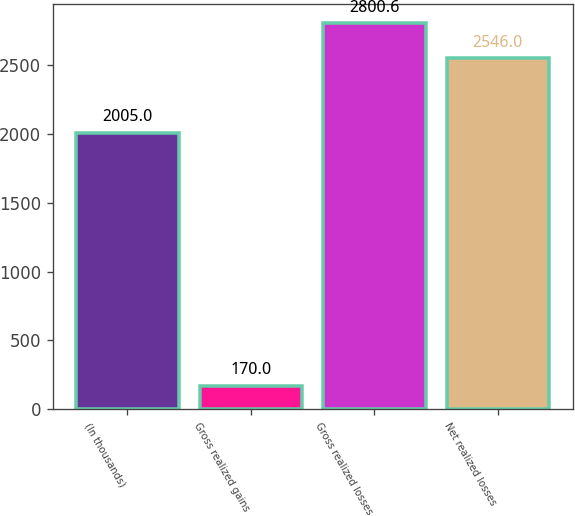<chart> <loc_0><loc_0><loc_500><loc_500><bar_chart><fcel>(In thousands)<fcel>Gross realized gains<fcel>Gross realized losses<fcel>Net realized losses<nl><fcel>2005<fcel>170<fcel>2800.6<fcel>2546<nl></chart> 